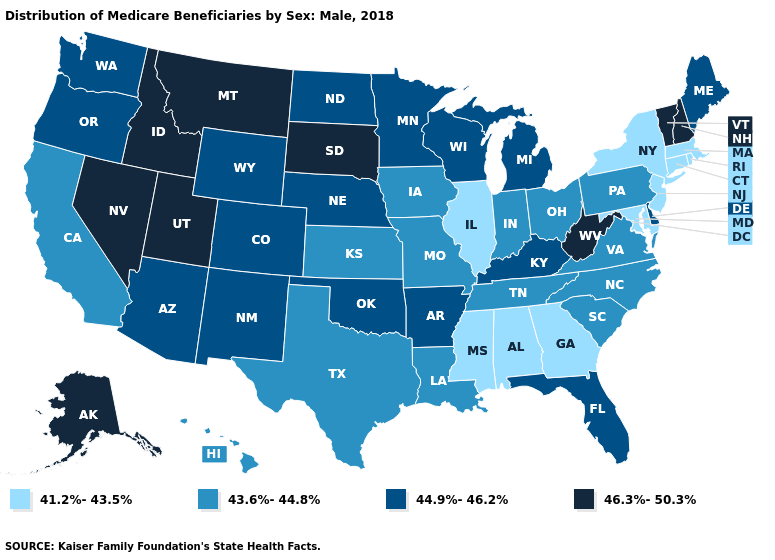What is the value of Iowa?
Be succinct. 43.6%-44.8%. Among the states that border Utah , which have the highest value?
Keep it brief. Idaho, Nevada. What is the value of South Carolina?
Be succinct. 43.6%-44.8%. Does Iowa have the same value as Hawaii?
Keep it brief. Yes. Does Oklahoma have the highest value in the South?
Answer briefly. No. What is the lowest value in the Northeast?
Keep it brief. 41.2%-43.5%. Name the states that have a value in the range 41.2%-43.5%?
Short answer required. Alabama, Connecticut, Georgia, Illinois, Maryland, Massachusetts, Mississippi, New Jersey, New York, Rhode Island. Does Nevada have a higher value than Montana?
Concise answer only. No. Does Virginia have a lower value than New Mexico?
Quick response, please. Yes. What is the value of Wisconsin?
Answer briefly. 44.9%-46.2%. Name the states that have a value in the range 44.9%-46.2%?
Quick response, please. Arizona, Arkansas, Colorado, Delaware, Florida, Kentucky, Maine, Michigan, Minnesota, Nebraska, New Mexico, North Dakota, Oklahoma, Oregon, Washington, Wisconsin, Wyoming. Which states have the highest value in the USA?
Quick response, please. Alaska, Idaho, Montana, Nevada, New Hampshire, South Dakota, Utah, Vermont, West Virginia. Does the map have missing data?
Short answer required. No. Name the states that have a value in the range 44.9%-46.2%?
Quick response, please. Arizona, Arkansas, Colorado, Delaware, Florida, Kentucky, Maine, Michigan, Minnesota, Nebraska, New Mexico, North Dakota, Oklahoma, Oregon, Washington, Wisconsin, Wyoming. 